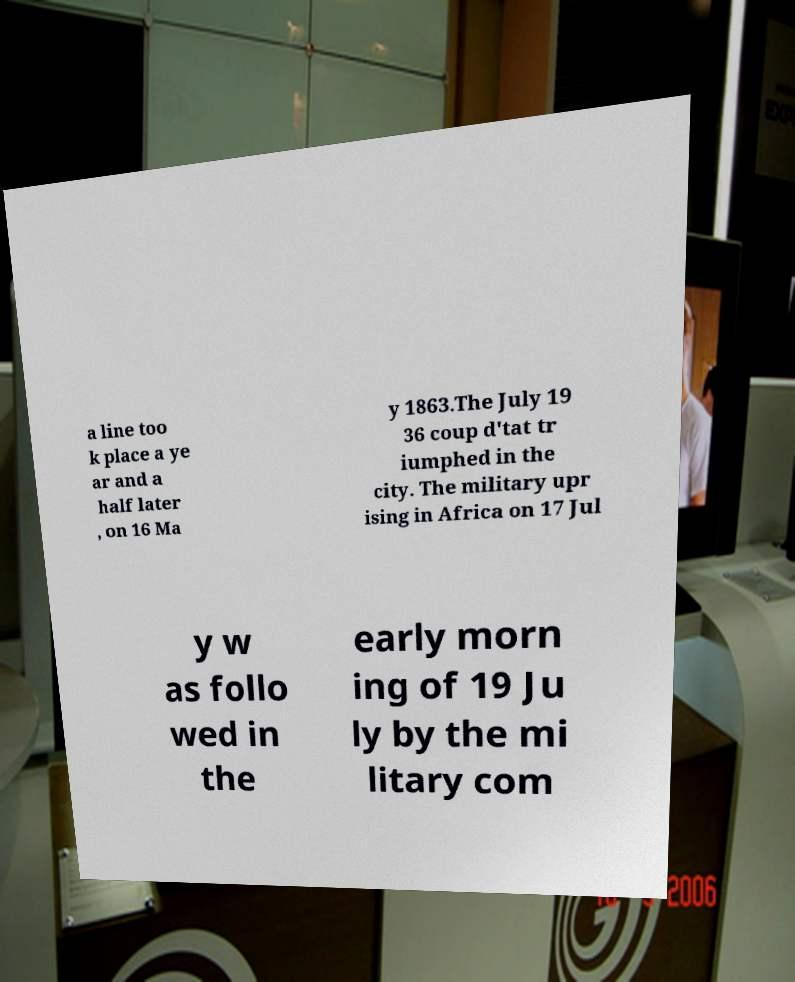Can you read and provide the text displayed in the image?This photo seems to have some interesting text. Can you extract and type it out for me? a line too k place a ye ar and a half later , on 16 Ma y 1863.The July 19 36 coup d'tat tr iumphed in the city. The military upr ising in Africa on 17 Jul y w as follo wed in the early morn ing of 19 Ju ly by the mi litary com 